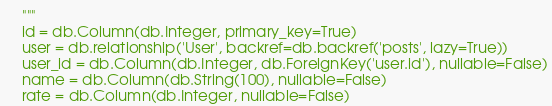<code> <loc_0><loc_0><loc_500><loc_500><_Python_>    """
    id = db.Column(db.Integer, primary_key=True)
    user = db.relationship('User', backref=db.backref('posts', lazy=True))
    user_id = db.Column(db.Integer, db.ForeignKey('user.id'), nullable=False)
    name = db.Column(db.String(100), nullable=False)
    rate = db.Column(db.Integer, nullable=False)
</code> 